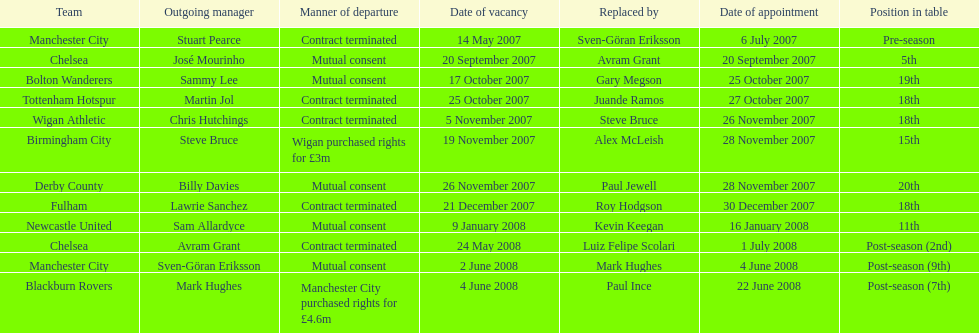Which new manager was purchased for the most money in the 2007-08 premier league season? Mark Hughes. Write the full table. {'header': ['Team', 'Outgoing manager', 'Manner of departure', 'Date of vacancy', 'Replaced by', 'Date of appointment', 'Position in table'], 'rows': [['Manchester City', 'Stuart Pearce', 'Contract terminated', '14 May 2007', 'Sven-Göran Eriksson', '6 July 2007', 'Pre-season'], ['Chelsea', 'José Mourinho', 'Mutual consent', '20 September 2007', 'Avram Grant', '20 September 2007', '5th'], ['Bolton Wanderers', 'Sammy Lee', 'Mutual consent', '17 October 2007', 'Gary Megson', '25 October 2007', '19th'], ['Tottenham Hotspur', 'Martin Jol', 'Contract terminated', '25 October 2007', 'Juande Ramos', '27 October 2007', '18th'], ['Wigan Athletic', 'Chris Hutchings', 'Contract terminated', '5 November 2007', 'Steve Bruce', '26 November 2007', '18th'], ['Birmingham City', 'Steve Bruce', 'Wigan purchased rights for £3m', '19 November 2007', 'Alex McLeish', '28 November 2007', '15th'], ['Derby County', 'Billy Davies', 'Mutual consent', '26 November 2007', 'Paul Jewell', '28 November 2007', '20th'], ['Fulham', 'Lawrie Sanchez', 'Contract terminated', '21 December 2007', 'Roy Hodgson', '30 December 2007', '18th'], ['Newcastle United', 'Sam Allardyce', 'Mutual consent', '9 January 2008', 'Kevin Keegan', '16 January 2008', '11th'], ['Chelsea', 'Avram Grant', 'Contract terminated', '24 May 2008', 'Luiz Felipe Scolari', '1 July 2008', 'Post-season (2nd)'], ['Manchester City', 'Sven-Göran Eriksson', 'Mutual consent', '2 June 2008', 'Mark Hughes', '4 June 2008', 'Post-season (9th)'], ['Blackburn Rovers', 'Mark Hughes', 'Manchester City purchased rights for £4.6m', '4 June 2008', 'Paul Ince', '22 June 2008', 'Post-season (7th)']]} 